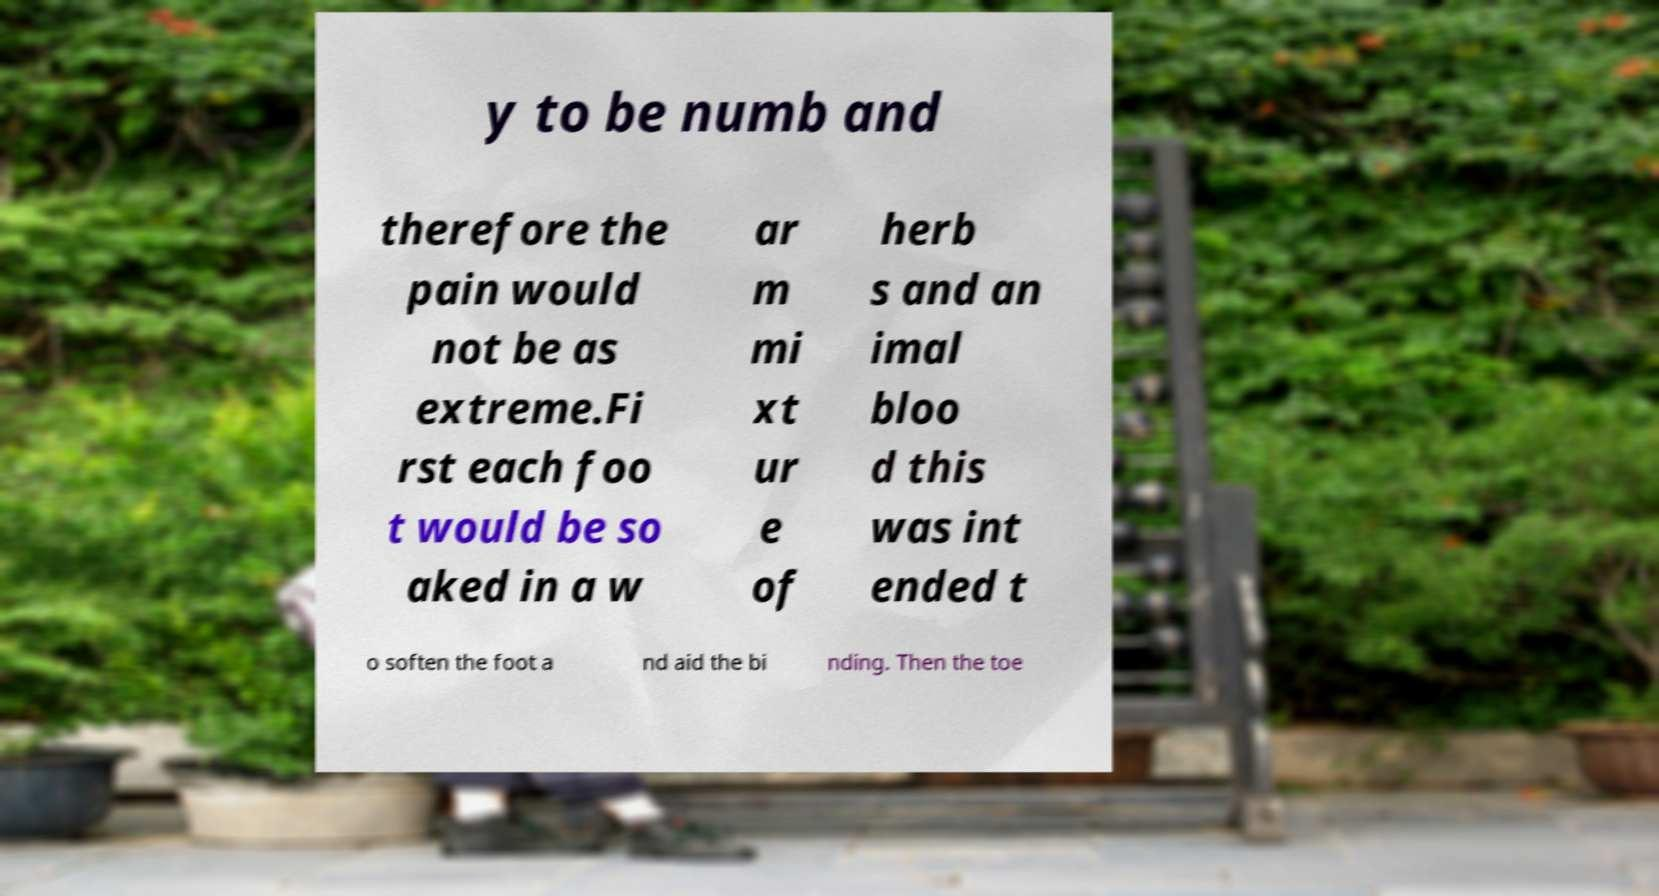There's text embedded in this image that I need extracted. Can you transcribe it verbatim? y to be numb and therefore the pain would not be as extreme.Fi rst each foo t would be so aked in a w ar m mi xt ur e of herb s and an imal bloo d this was int ended t o soften the foot a nd aid the bi nding. Then the toe 